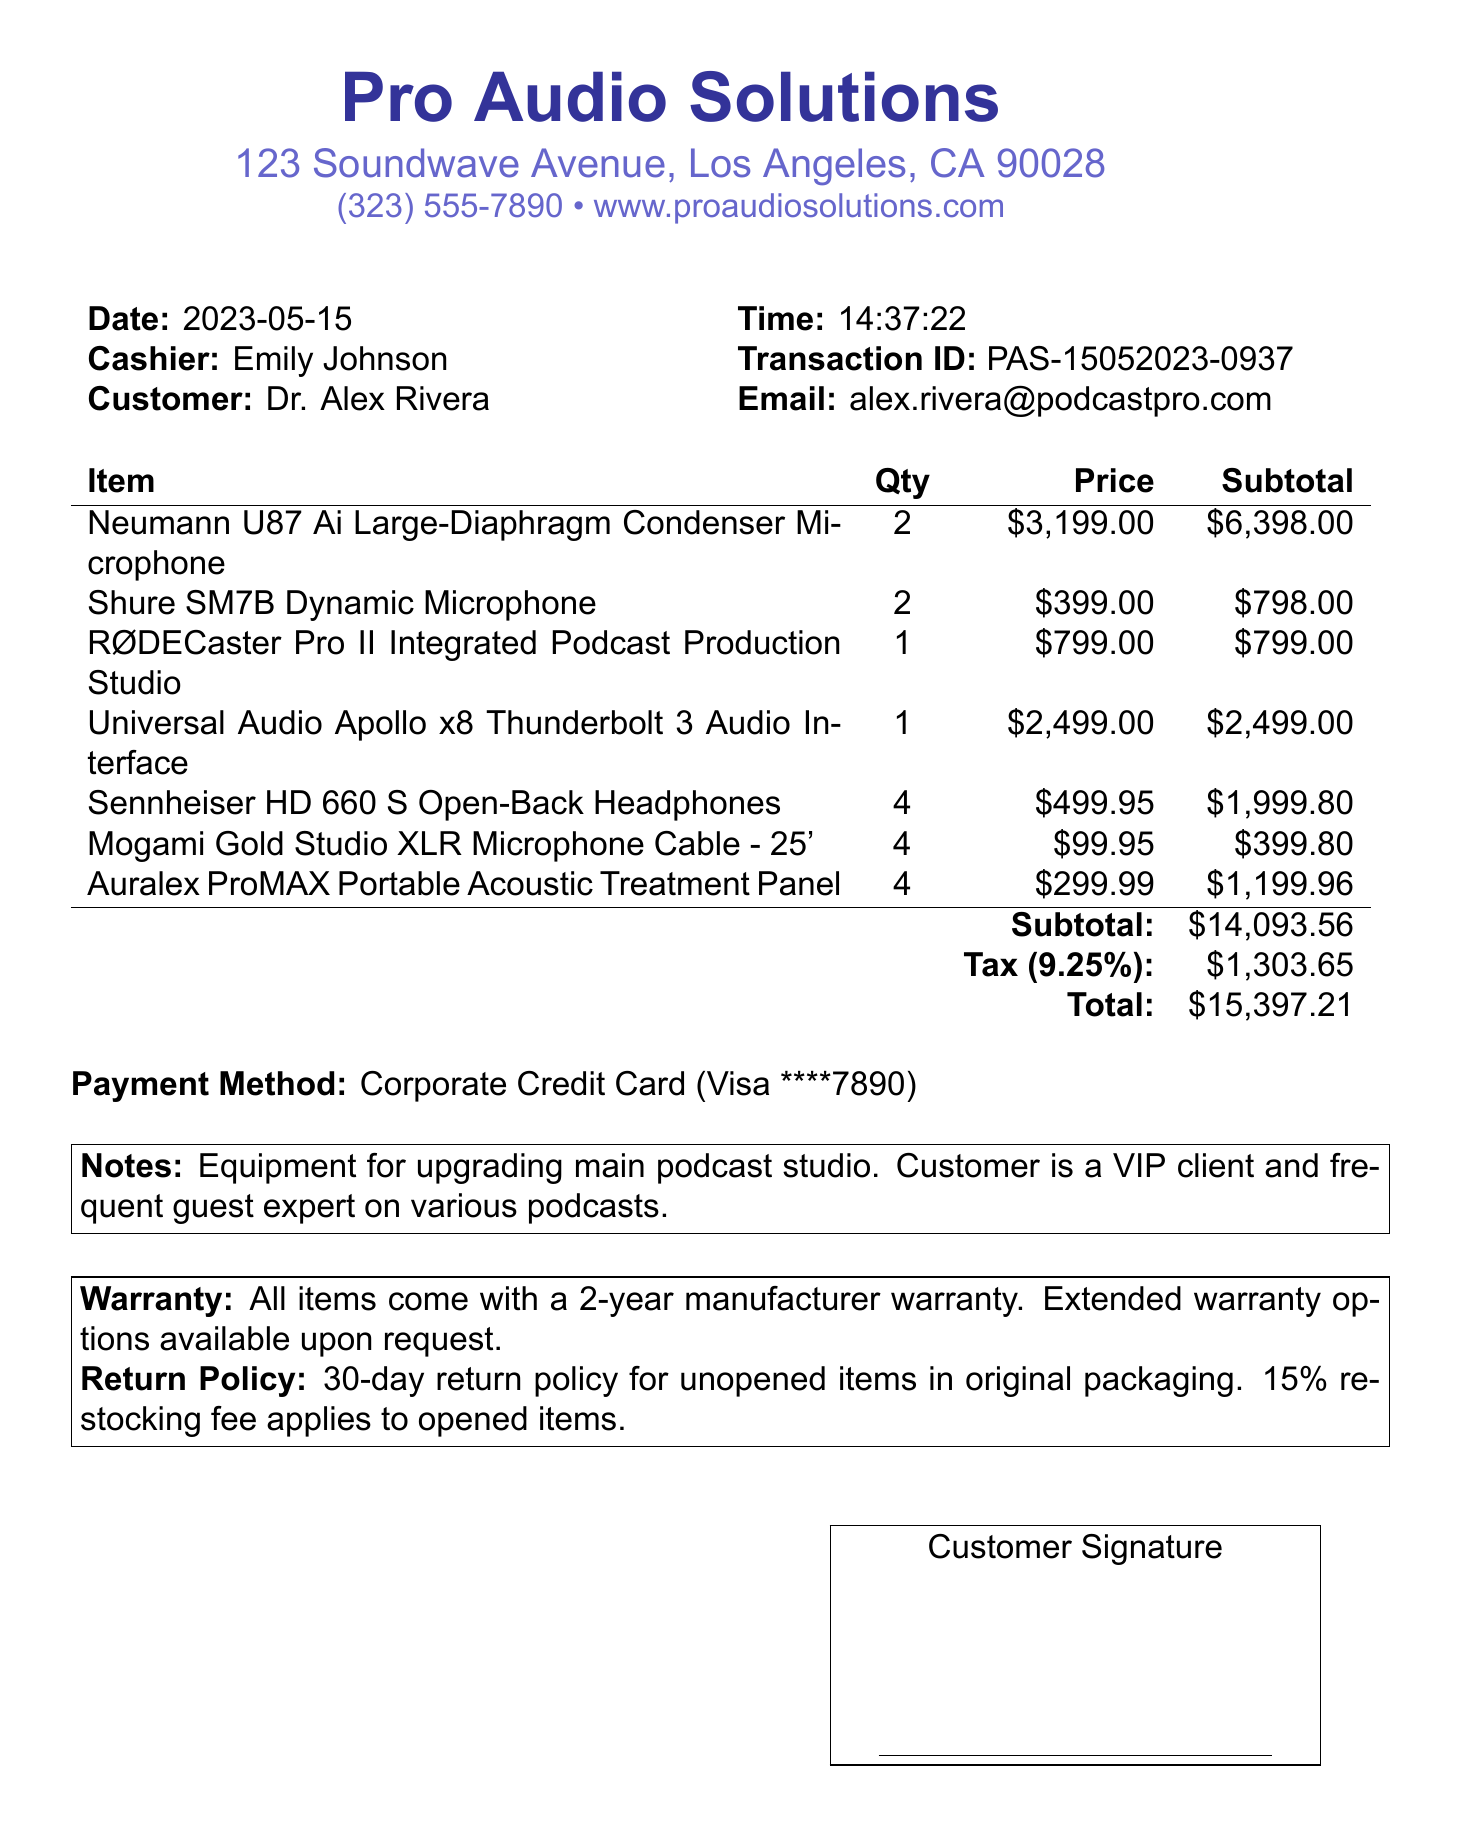What is the name of the store? The store name is Pro Audio Solutions, as stated at the top of the document.
Answer: Pro Audio Solutions What items were purchased? The items purchased include microphones, a mixer, headphones, cables, and acoustic treatment panels, as detailed in the itemized list.
Answer: Neumann U87 Ai, Shure SM7B, RØDECaster Pro II, Apollo x8, Sennheiser HD 660 S, Mogami Gold Cable, Auralex ProMAX What is the total amount paid? The total amount paid is calculated as subtotal plus tax, which totals to $15,397.21 in the document.
Answer: $15,397.21 Who is the customer? The customer is identified as Dr. Alex Rivera at the top of the transaction details.
Answer: Dr. Alex Rivera What is the cashiers name? The cashier's name is provided in the transaction details section of the document.
Answer: Emily Johnson When was the purchase made? The date of the purchase is clearly stated in the header information of the receipt.
Answer: 2023-05-15 What is the warranty period for the items? The warranty information specifies that all items come with a 2-year manufacturer warranty.
Answer: 2-year Is a signature required for this purchase? The document includes a note indicating that a signature is required for this transaction.
Answer: Yes What is the return policy for unopened items? The return policy for unopened items states that they can be returned within 30 days in original packaging.
Answer: 30-day return policy 